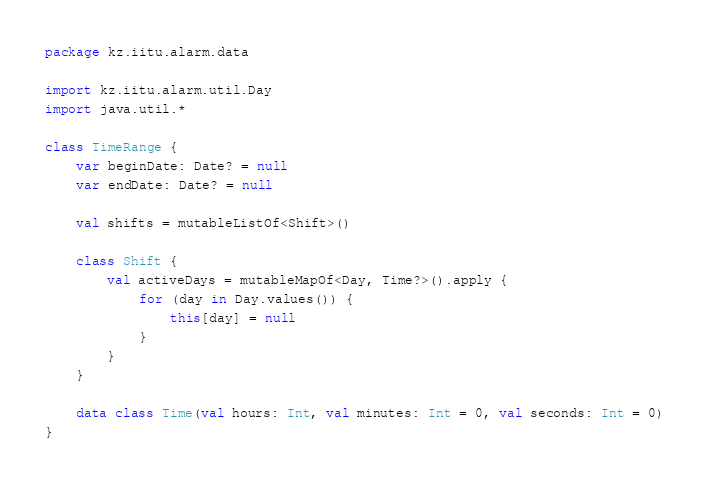<code> <loc_0><loc_0><loc_500><loc_500><_Kotlin_>package kz.iitu.alarm.data

import kz.iitu.alarm.util.Day
import java.util.*

class TimeRange {
    var beginDate: Date? = null
    var endDate: Date? = null

    val shifts = mutableListOf<Shift>()

    class Shift {
        val activeDays = mutableMapOf<Day, Time?>().apply {
            for (day in Day.values()) {
                this[day] = null
            }
        }
    }

    data class Time(val hours: Int, val minutes: Int = 0, val seconds: Int = 0)
}</code> 